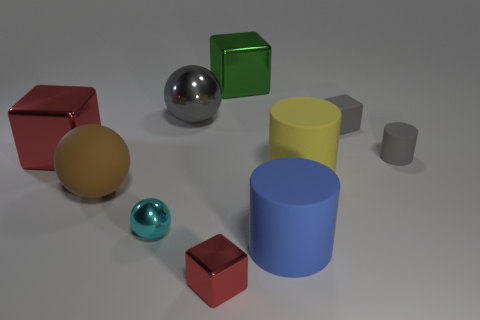There is a big yellow matte thing; is its shape the same as the large brown matte object that is behind the small cyan object?
Make the answer very short. No. What number of other cylinders have the same size as the blue matte cylinder?
Provide a short and direct response. 1. How many rubber cubes are in front of the metallic cube in front of the large rubber object that is behind the big brown object?
Your response must be concise. 0. Are there an equal number of things to the right of the big green block and metallic spheres that are on the left side of the large brown sphere?
Provide a succinct answer. No. What number of other brown things are the same shape as the large brown object?
Provide a short and direct response. 0. Are there any brown objects made of the same material as the big yellow object?
Offer a terse response. Yes. The large metal object that is the same color as the small cylinder is what shape?
Make the answer very short. Sphere. How many gray rubber cubes are there?
Your response must be concise. 1. What number of blocks are either small metallic things or cyan objects?
Your answer should be compact. 1. The other matte ball that is the same size as the gray sphere is what color?
Provide a short and direct response. Brown. 